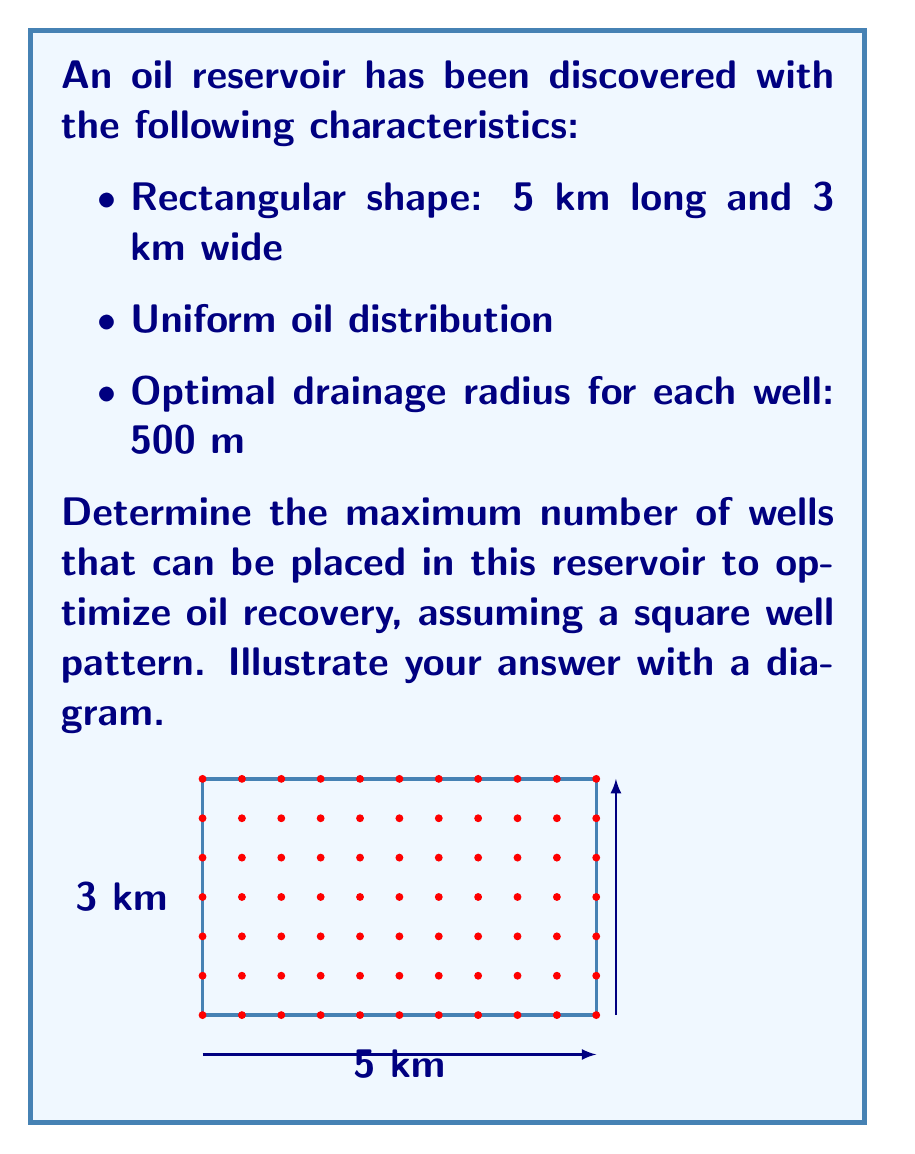Can you solve this math problem? To optimize well spacing for maximum oil recovery, we need to determine the number of wells that can fit within the reservoir while maintaining the optimal drainage radius. Let's approach this step-by-step:

1) The optimal drainage radius is 500 m, which means each well should be at the center of a 1 km × 1 km square (500 m radius in each direction).

2) We need to calculate how many 1 km × 1 km squares can fit within the 5 km × 3 km reservoir.

3) For the length (5 km):
   Number of wells along length = $\lfloor \frac{5 \text{ km}}{1 \text{ km}} \rfloor = 5$ wells
   
4) For the width (3 km):
   Number of wells along width = $\lfloor \frac{3 \text{ km}}{1 \text{ km}} \rfloor = 3$ wells

5) The total number of wells is the product of wells along length and width:
   Total wells = 5 × 3 = 15 wells

6) We can verify this by calculating the area:
   Area of reservoir: 5 km × 3 km = 15 km²
   Area covered by each well: 1 km × 1 km = 1 km²
   Maximum number of wells = $\frac{15 \text{ km}²}{1 \text{ km}²} = 15$ wells

Therefore, the maximum number of wells that can be placed in this reservoir to optimize oil recovery is 15, arranged in a 5 × 3 grid pattern.
Answer: 15 wells 